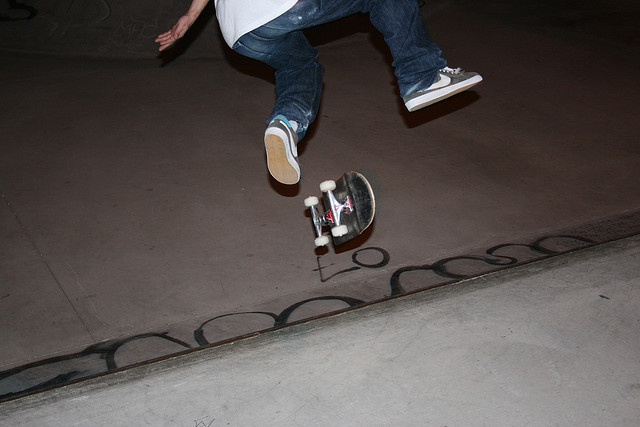Describe the objects in this image and their specific colors. I can see people in black, navy, lightgray, and gray tones and skateboard in black, gray, lightgray, and darkgray tones in this image. 